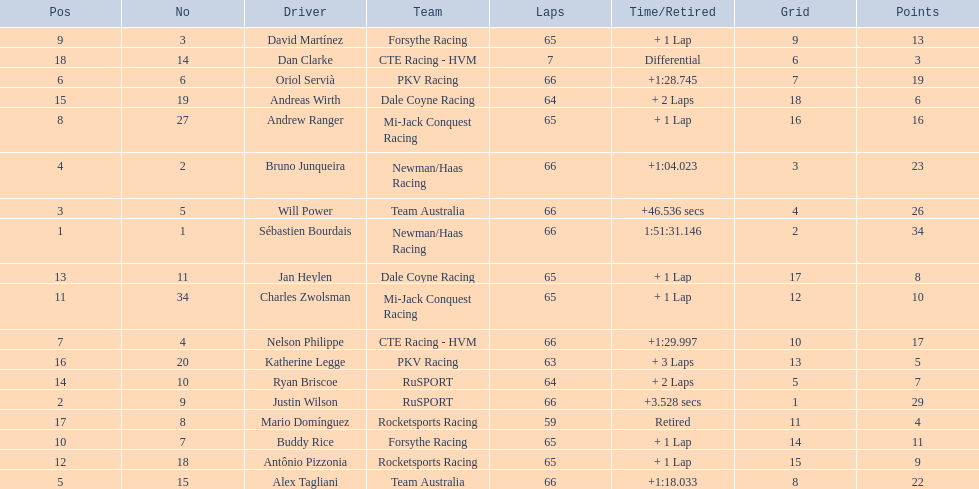Write the full table. {'header': ['Pos', 'No', 'Driver', 'Team', 'Laps', 'Time/Retired', 'Grid', 'Points'], 'rows': [['9', '3', 'David Martínez', 'Forsythe Racing', '65', '+ 1 Lap', '9', '13'], ['18', '14', 'Dan Clarke', 'CTE Racing - HVM', '7', 'Differential', '6', '3'], ['6', '6', 'Oriol Servià', 'PKV Racing', '66', '+1:28.745', '7', '19'], ['15', '19', 'Andreas Wirth', 'Dale Coyne Racing', '64', '+ 2 Laps', '18', '6'], ['8', '27', 'Andrew Ranger', 'Mi-Jack Conquest Racing', '65', '+ 1 Lap', '16', '16'], ['4', '2', 'Bruno Junqueira', 'Newman/Haas Racing', '66', '+1:04.023', '3', '23'], ['3', '5', 'Will Power', 'Team Australia', '66', '+46.536 secs', '4', '26'], ['1', '1', 'Sébastien Bourdais', 'Newman/Haas Racing', '66', '1:51:31.146', '2', '34'], ['13', '11', 'Jan Heylen', 'Dale Coyne Racing', '65', '+ 1 Lap', '17', '8'], ['11', '34', 'Charles Zwolsman', 'Mi-Jack Conquest Racing', '65', '+ 1 Lap', '12', '10'], ['7', '4', 'Nelson Philippe', 'CTE Racing - HVM', '66', '+1:29.997', '10', '17'], ['16', '20', 'Katherine Legge', 'PKV Racing', '63', '+ 3 Laps', '13', '5'], ['14', '10', 'Ryan Briscoe', 'RuSPORT', '64', '+ 2 Laps', '5', '7'], ['2', '9', 'Justin Wilson', 'RuSPORT', '66', '+3.528 secs', '1', '29'], ['17', '8', 'Mario Domínguez', 'Rocketsports Racing', '59', 'Retired', '11', '4'], ['10', '7', 'Buddy Rice', 'Forsythe Racing', '65', '+ 1 Lap', '14', '11'], ['12', '18', 'Antônio Pizzonia', 'Rocketsports Racing', '65', '+ 1 Lap', '15', '9'], ['5', '15', 'Alex Tagliani', 'Team Australia', '66', '+1:18.033', '8', '22']]} Who are all the drivers? Sébastien Bourdais, Justin Wilson, Will Power, Bruno Junqueira, Alex Tagliani, Oriol Servià, Nelson Philippe, Andrew Ranger, David Martínez, Buddy Rice, Charles Zwolsman, Antônio Pizzonia, Jan Heylen, Ryan Briscoe, Andreas Wirth, Katherine Legge, Mario Domínguez, Dan Clarke. What position did they reach? 1, 2, 3, 4, 5, 6, 7, 8, 9, 10, 11, 12, 13, 14, 15, 16, 17, 18. What is the number for each driver? 1, 9, 5, 2, 15, 6, 4, 27, 3, 7, 34, 18, 11, 10, 19, 20, 8, 14. And which player's number and position match? Sébastien Bourdais. 